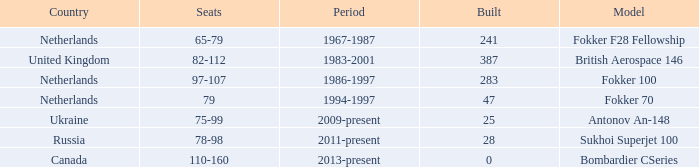Would you mind parsing the complete table? {'header': ['Country', 'Seats', 'Period', 'Built', 'Model'], 'rows': [['Netherlands', '65-79', '1967-1987', '241', 'Fokker F28 Fellowship'], ['United Kingdom', '82-112', '1983-2001', '387', 'British Aerospace 146'], ['Netherlands', '97-107', '1986-1997', '283', 'Fokker 100'], ['Netherlands', '79', '1994-1997', '47', 'Fokker 70'], ['Ukraine', '75-99', '2009-present', '25', 'Antonov An-148'], ['Russia', '78-98', '2011-present', '28', 'Sukhoi Superjet 100'], ['Canada', '110-160', '2013-present', '0', 'Bombardier CSeries']]} Between which years were there 241 fokker 70 model cabins built? 1994-1997. 